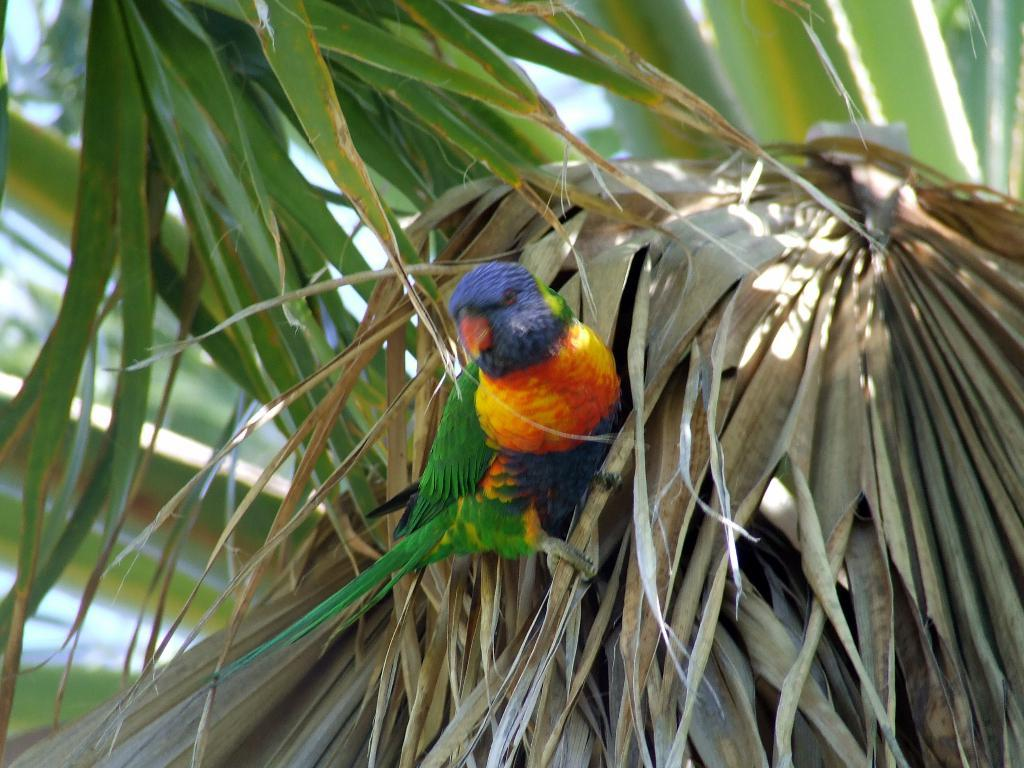What type of animal is in the image? There is a bird in the image. What colors can be seen on the bird? The bird has green, yellow, yellow, orange, and blue colors. What is the bird standing on? The bird is on dried leaves. What type of vegetation is visible in the background of the image? There are green leaves in the background of the image. What type of disease is affecting the bird in the image? There is no indication of any disease affecting the bird in the image. Can you see an island in the background of the image? There is no island visible in the image; it features a bird on dried leaves with green leaves in the background. 